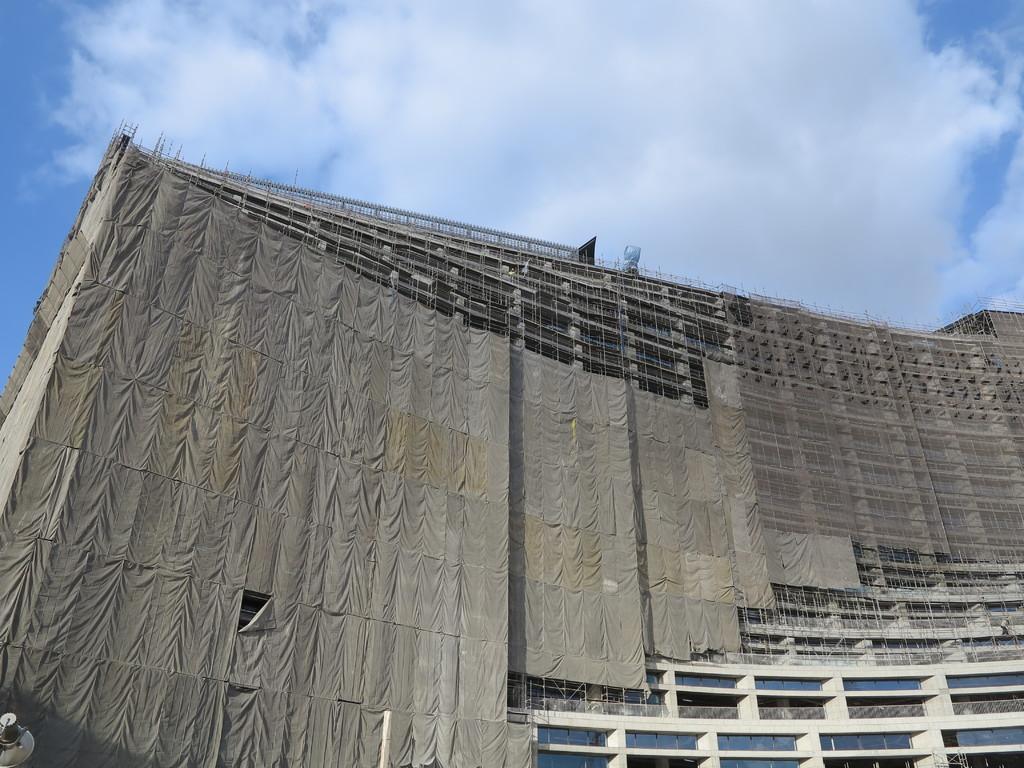Can you describe this image briefly? In this image I can see a building in the front and on the top side of the image I can see clouds and the sky. On the bottom side of the image I can see a pole and on the bottom left corner of the image I can see a light like thing. 